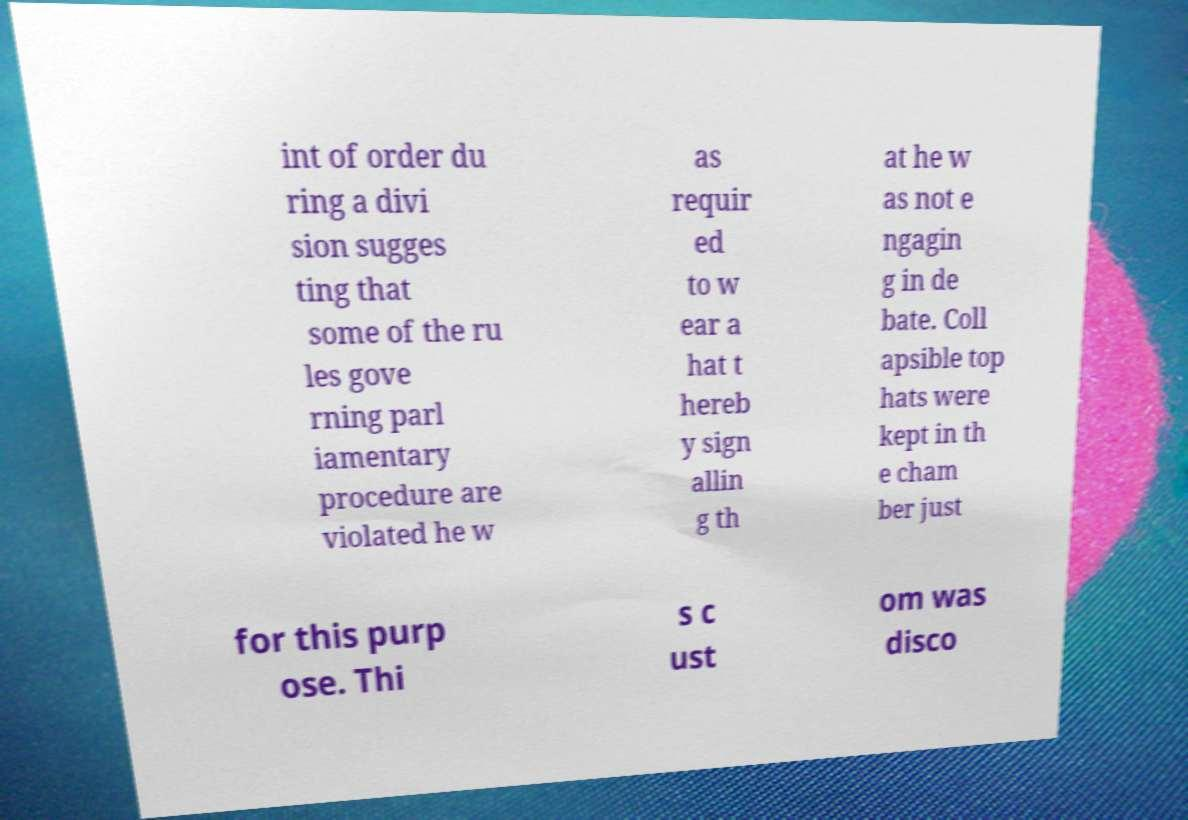What messages or text are displayed in this image? I need them in a readable, typed format. int of order du ring a divi sion sugges ting that some of the ru les gove rning parl iamentary procedure are violated he w as requir ed to w ear a hat t hereb y sign allin g th at he w as not e ngagin g in de bate. Coll apsible top hats were kept in th e cham ber just for this purp ose. Thi s c ust om was disco 